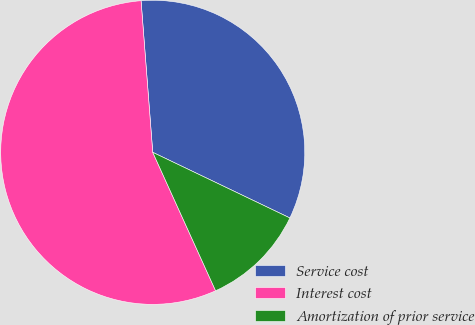Convert chart to OTSL. <chart><loc_0><loc_0><loc_500><loc_500><pie_chart><fcel>Service cost<fcel>Interest cost<fcel>Amortization of prior service<nl><fcel>33.33%<fcel>55.56%<fcel>11.11%<nl></chart> 